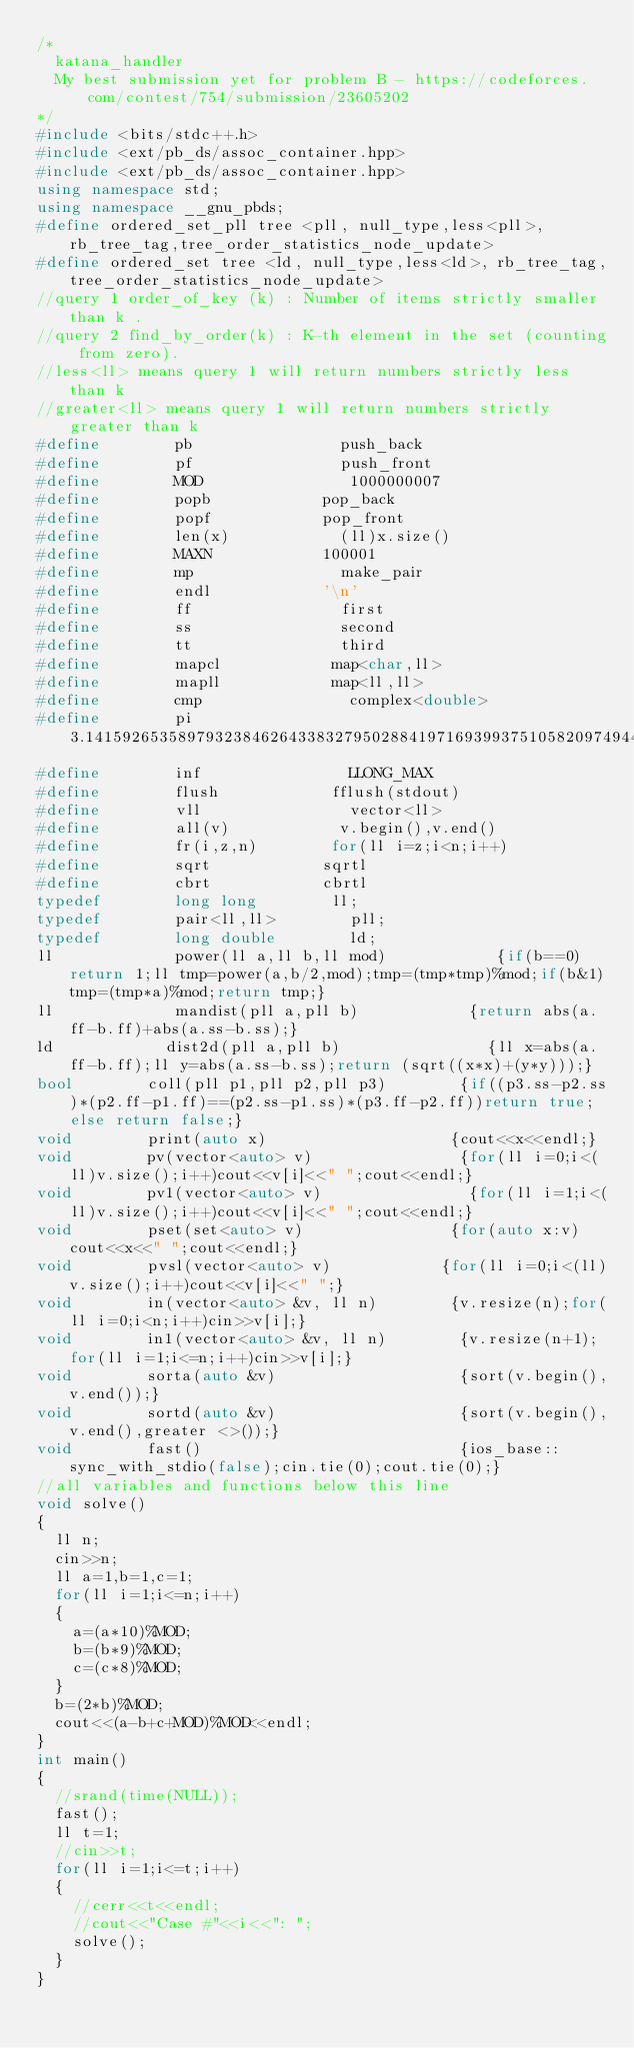<code> <loc_0><loc_0><loc_500><loc_500><_C++_>/*
	katana_handler
	My best submission yet for problem B - https://codeforces.com/contest/754/submission/23605202
*/
#include <bits/stdc++.h>
#include <ext/pb_ds/assoc_container.hpp>
#include <ext/pb_ds/assoc_container.hpp>
using namespace std;
using namespace __gnu_pbds;
#define ordered_set_pll tree <pll, null_type,less<pll>, rb_tree_tag,tree_order_statistics_node_update>
#define ordered_set tree <ld, null_type,less<ld>, rb_tree_tag,tree_order_statistics_node_update>
//query 1 order_of_key (k) : Number of items strictly smaller than k .
//query 2 find_by_order(k) : K-th element in the set (counting from zero).
//less<ll> means query 1 will return numbers strictly less than k
//greater<ll> means query 1 will return numbers strictly greater than k
#define        pb                push_back
#define        pf                push_front
#define        MOD                1000000007
#define        popb            pop_back
#define        popf            pop_front
#define        len(x)            (ll)x.size()    
#define        MAXN            100001
#define        mp                make_pair
#define        endl            '\n'
#define        ff                first
#define        ss                second
#define        tt                third
#define        mapcl            map<char,ll>
#define        mapll            map<ll,ll>
#define        cmp                complex<double>
#define        pi                3.141592653589793238462643383279502884197169399375105820974944592307816406286
#define        inf                LLONG_MAX
#define        flush            fflush(stdout)
#define        vll                vector<ll>
#define        all(v)            v.begin(),v.end()
#define        fr(i,z,n)        for(ll i=z;i<n;i++)
#define        sqrt            sqrtl
#define        cbrt            cbrtl
typedef        long long        ll;
typedef        pair<ll,ll>        pll;
typedef        long double        ld;
ll             power(ll a,ll b,ll mod)            {if(b==0)return 1;ll tmp=power(a,b/2,mod);tmp=(tmp*tmp)%mod;if(b&1)tmp=(tmp*a)%mod;return tmp;}
ll             mandist(pll a,pll b)            {return abs(a.ff-b.ff)+abs(a.ss-b.ss);}
ld            dist2d(pll a,pll b)                {ll x=abs(a.ff-b.ff);ll y=abs(a.ss-b.ss);return (sqrt((x*x)+(y*y)));}
bool        coll(pll p1,pll p2,pll p3)        {if((p3.ss-p2.ss)*(p2.ff-p1.ff)==(p2.ss-p1.ss)*(p3.ff-p2.ff))return true;else return false;}
void        print(auto x)                    {cout<<x<<endl;}
void        pv(vector<auto> v)                {for(ll i=0;i<(ll)v.size();i++)cout<<v[i]<<" ";cout<<endl;}
void        pv1(vector<auto> v)                {for(ll i=1;i<(ll)v.size();i++)cout<<v[i]<<" ";cout<<endl;}
void        pset(set<auto> v)                {for(auto x:v)cout<<x<<" ";cout<<endl;}
void        pvsl(vector<auto> v)            {for(ll i=0;i<(ll)v.size();i++)cout<<v[i]<<" ";}
void        in(vector<auto> &v, ll n)        {v.resize(n);for(ll i=0;i<n;i++)cin>>v[i];}
void        in1(vector<auto> &v, ll n)        {v.resize(n+1);for(ll i=1;i<=n;i++)cin>>v[i];}
void        sorta(auto &v)                    {sort(v.begin(),v.end());}
void        sortd(auto &v)                    {sort(v.begin(),v.end(),greater <>());}		
void        fast()                            {ios_base::sync_with_stdio(false);cin.tie(0);cout.tie(0);}
//all variables and functions below this line
void solve()
{
	ll n;
	cin>>n;
	ll a=1,b=1,c=1;
	for(ll i=1;i<=n;i++)
	{
		a=(a*10)%MOD;
		b=(b*9)%MOD;
		c=(c*8)%MOD;
	}
	b=(2*b)%MOD;
	cout<<(a-b+c+MOD)%MOD<<endl;
}
int main()
{
	//srand(time(NULL));
	fast();
	ll t=1;
	//cin>>t;
	for(ll i=1;i<=t;i++)
	{
		//cerr<<t<<endl;
		//cout<<"Case #"<<i<<": ";
		solve();
	}
}
</code> 